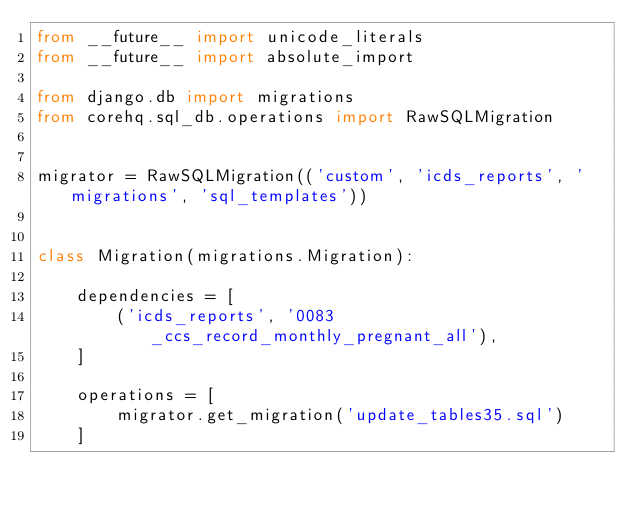<code> <loc_0><loc_0><loc_500><loc_500><_Python_>from __future__ import unicode_literals
from __future__ import absolute_import

from django.db import migrations
from corehq.sql_db.operations import RawSQLMigration


migrator = RawSQLMigration(('custom', 'icds_reports', 'migrations', 'sql_templates'))


class Migration(migrations.Migration):

    dependencies = [
        ('icds_reports', '0083_ccs_record_monthly_pregnant_all'),
    ]

    operations = [
        migrator.get_migration('update_tables35.sql')
    ]
</code> 